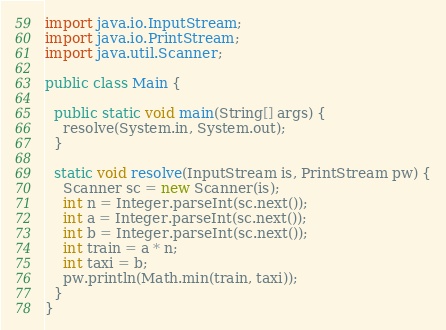<code> <loc_0><loc_0><loc_500><loc_500><_Java_>import java.io.InputStream;
import java.io.PrintStream;
import java.util.Scanner;

public class Main {

  public static void main(String[] args) {
    resolve(System.in, System.out);
  }

  static void resolve(InputStream is, PrintStream pw) {
    Scanner sc = new Scanner(is);
    int n = Integer.parseInt(sc.next());
    int a = Integer.parseInt(sc.next());
    int b = Integer.parseInt(sc.next());
    int train = a * n;
    int taxi = b;
    pw.println(Math.min(train, taxi));
  }
}
</code> 